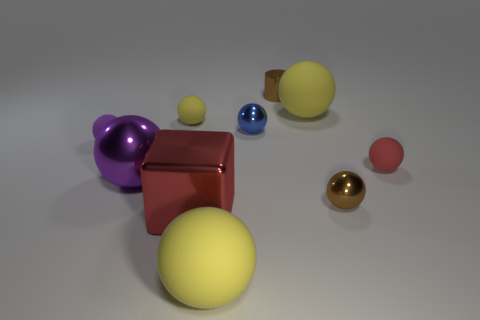Subtract all large spheres. How many spheres are left? 5 Subtract 1 red spheres. How many objects are left? 9 How many yellow balls must be subtracted to get 2 yellow balls? 1 Subtract all cylinders. How many objects are left? 9 Subtract 1 blocks. How many blocks are left? 0 Subtract all green balls. Subtract all blue cylinders. How many balls are left? 8 Subtract all yellow cylinders. How many cyan blocks are left? 0 Subtract all small cyan matte cubes. Subtract all tiny brown objects. How many objects are left? 8 Add 2 large metallic balls. How many large metallic balls are left? 3 Add 7 small yellow rubber blocks. How many small yellow rubber blocks exist? 7 